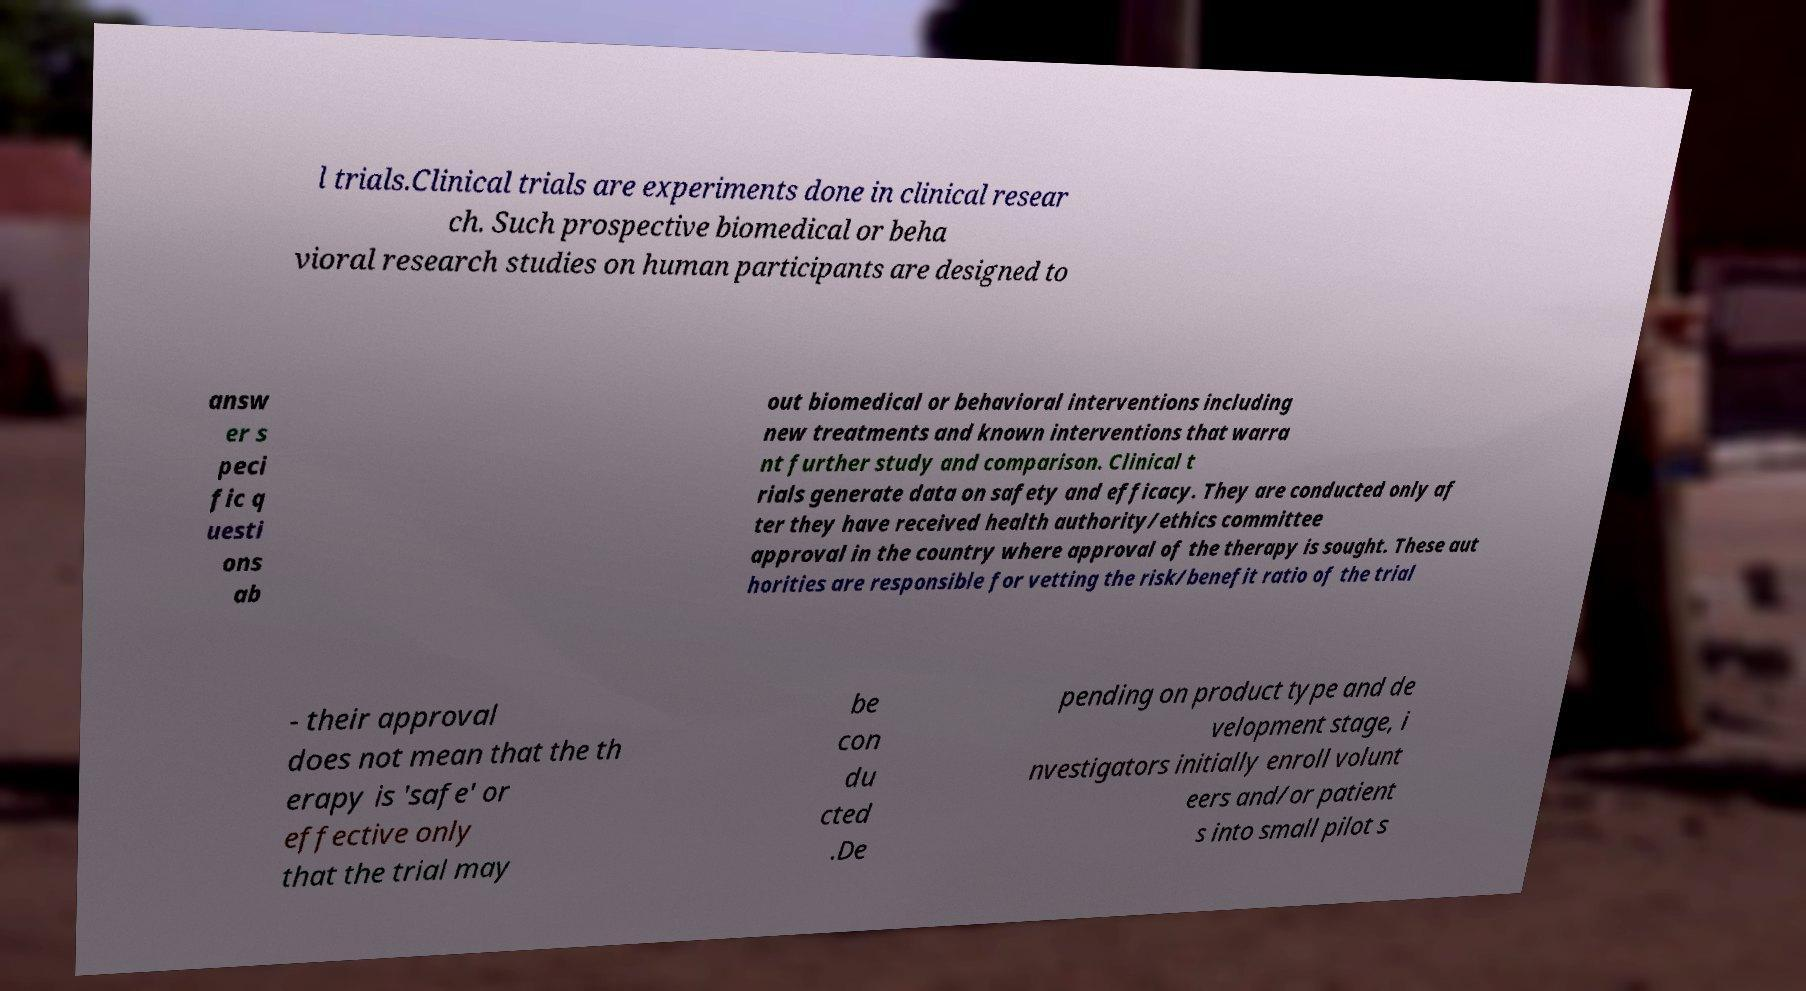Please identify and transcribe the text found in this image. l trials.Clinical trials are experiments done in clinical resear ch. Such prospective biomedical or beha vioral research studies on human participants are designed to answ er s peci fic q uesti ons ab out biomedical or behavioral interventions including new treatments and known interventions that warra nt further study and comparison. Clinical t rials generate data on safety and efficacy. They are conducted only af ter they have received health authority/ethics committee approval in the country where approval of the therapy is sought. These aut horities are responsible for vetting the risk/benefit ratio of the trial - their approval does not mean that the th erapy is 'safe' or effective only that the trial may be con du cted .De pending on product type and de velopment stage, i nvestigators initially enroll volunt eers and/or patient s into small pilot s 